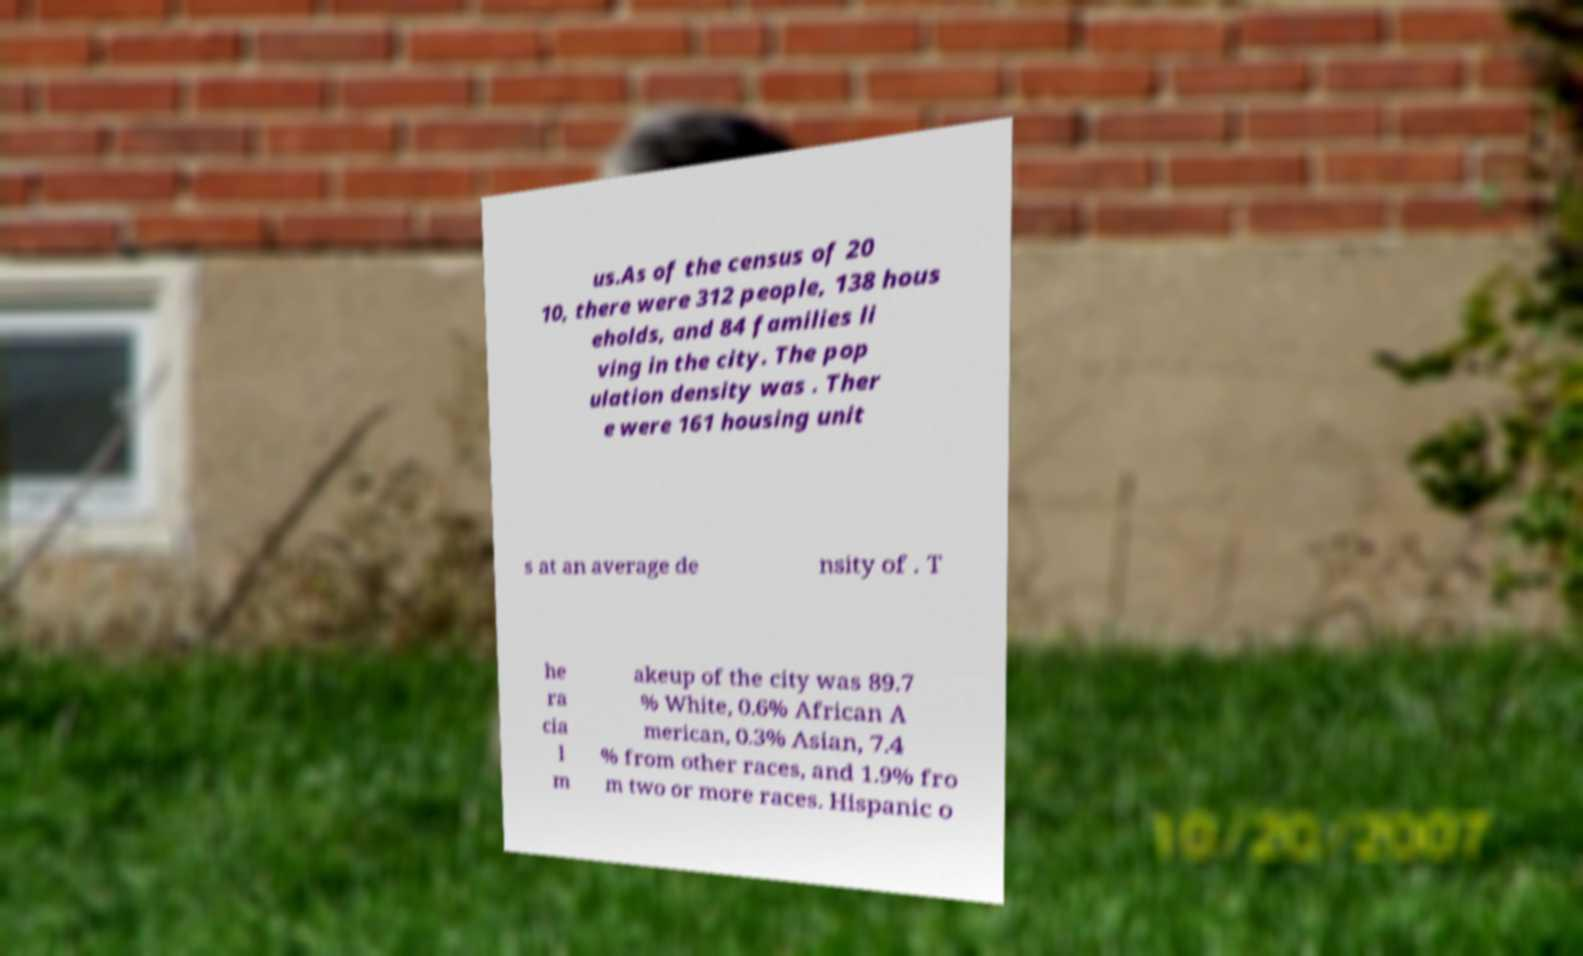Could you assist in decoding the text presented in this image and type it out clearly? us.As of the census of 20 10, there were 312 people, 138 hous eholds, and 84 families li ving in the city. The pop ulation density was . Ther e were 161 housing unit s at an average de nsity of . T he ra cia l m akeup of the city was 89.7 % White, 0.6% African A merican, 0.3% Asian, 7.4 % from other races, and 1.9% fro m two or more races. Hispanic o 